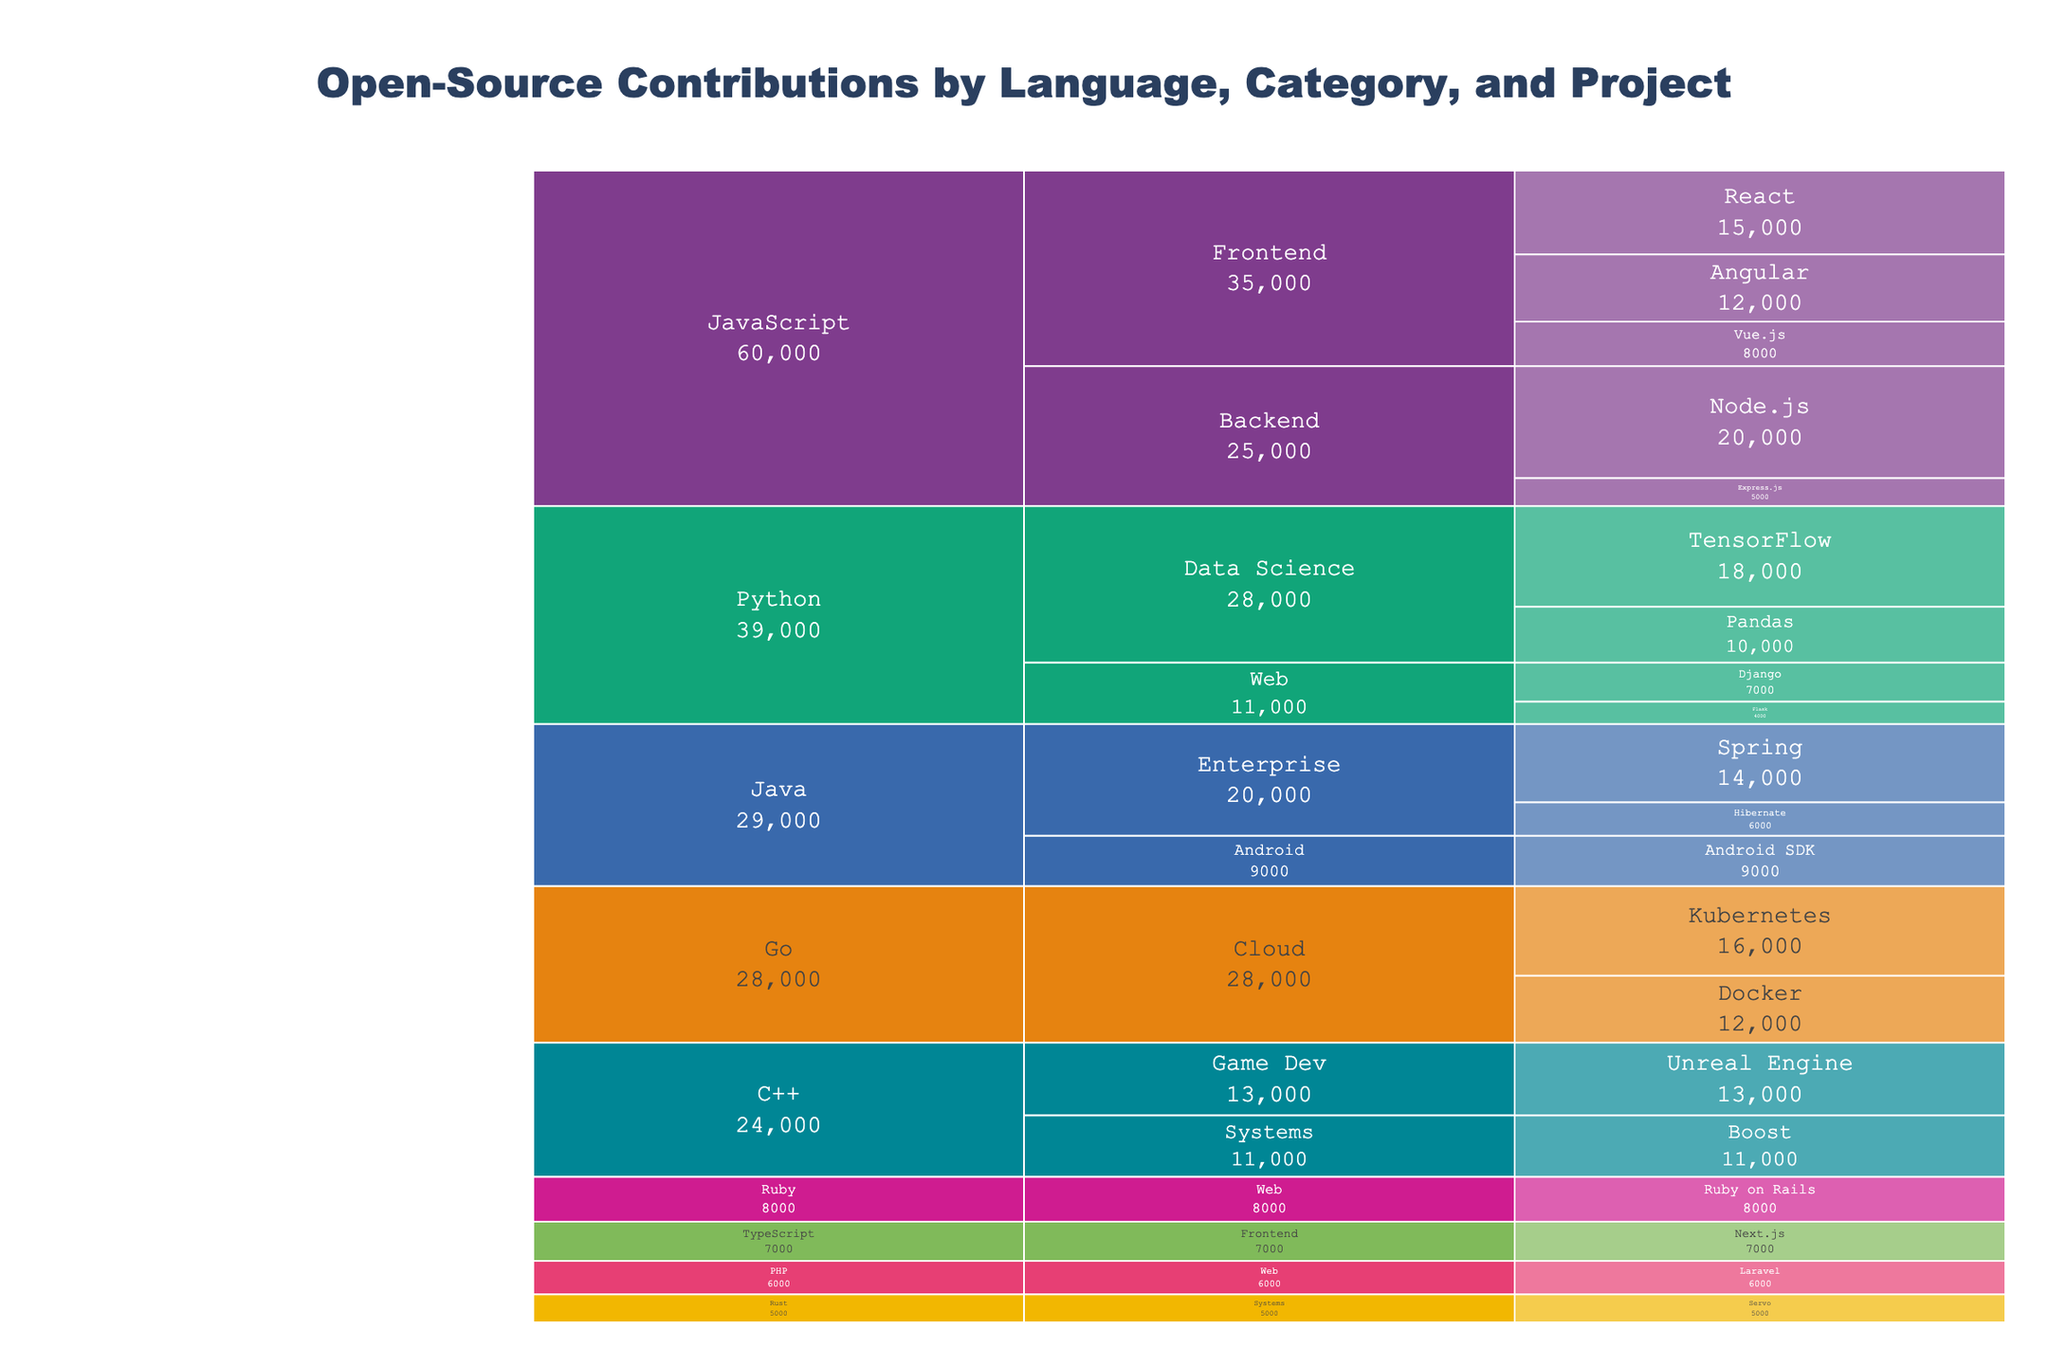What is the overall title of the icicle chart? The title is displayed prominently at the top of the icicle chart, and it gives an overview of the content being presented.
Answer: "Open-Source Contributions by Language, Category, and Project" Which programming language has the highest total contributions? To find this, look at the segments for each programming language and sum their contributions. JavaScript has the largest segments overall, indicating the highest total contributions.
Answer: JavaScript How many contributions are there for the Node.js project? Node.js is a part of the Backend category under JavaScript. The contributions are indicated on the chart next to the Node.js label.
Answer: 20000 What are the total contributions for Python projects in Data Science? Add up the contributions for TensorFlow and Pandas under the Data Science category in Python.
Answer: 18000 + 10000 = 28000 Compare the contributions between Kubernetes and Docker projects. Which one has more? Kubernetes and Docker are both part of the Cloud category under Go. Compare the numerical values next to their labels.
Answer: Kubernetes has 16000; Docker has 12000. Kubernetes has more What is the difference in contributions between the React and Angular projects? Subtract the contributions for Angular from those for React in the Frontend category under JavaScript.
Answer: 15000 - 12000 = 3000 Which programming language has the fewest total contributions and what are the projects under it? Look at all the segments for each programming language and sum their contributions. Rust has the fewest contributions and its project is Servo.
Answer: Rust, Servo What are the total contributions for projects in the Web category? Add up the contributions for Django, Flask, Ruby on Rails, and Laravel.
Answer: 7000 (Django) + 4000 (Flask) + 8000 (Ruby on Rails) + 6000 (Laravel) = 25000 Identify the project with the highest contributions in the Systems category. Compare the contributions for Boost and Servo in the Systems category under C++ and Rust respectively.
Answer: Boost has 11000; Servo has 5000. Boost has the highest contributions How many contributions are there in total for Frontend projects in JavaScript? Add up the contributions for React, Vue.js, and Angular in the Frontend category under JavaScript.
Answer: 15000 (React) + 8000 (Vue.js) + 12000 (Angular) = 35000 